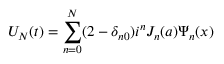<formula> <loc_0><loc_0><loc_500><loc_500>U _ { N } ( t ) = \sum _ { n = 0 } ^ { N } ( 2 - \delta _ { n 0 } ) i ^ { n } J _ { n } ( a ) \Psi _ { n } ( x )</formula> 